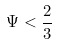Convert formula to latex. <formula><loc_0><loc_0><loc_500><loc_500>\Psi < \frac { 2 } { 3 }</formula> 